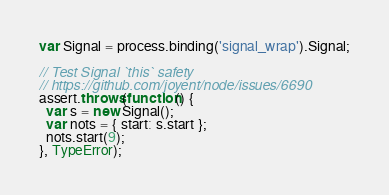Convert code to text. <code><loc_0><loc_0><loc_500><loc_500><_JavaScript_>var Signal = process.binding('signal_wrap').Signal;

// Test Signal `this` safety
// https://github.com/joyent/node/issues/6690
assert.throws(function() {
  var s = new Signal();
  var nots = { start: s.start };
  nots.start(9);
}, TypeError);
</code> 